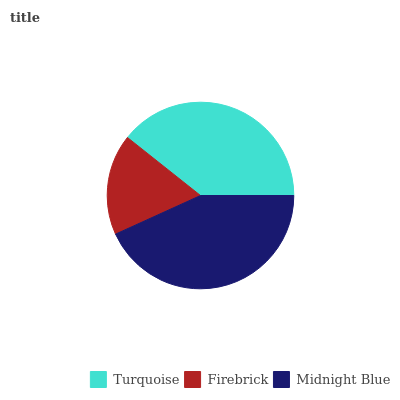Is Firebrick the minimum?
Answer yes or no. Yes. Is Midnight Blue the maximum?
Answer yes or no. Yes. Is Midnight Blue the minimum?
Answer yes or no. No. Is Firebrick the maximum?
Answer yes or no. No. Is Midnight Blue greater than Firebrick?
Answer yes or no. Yes. Is Firebrick less than Midnight Blue?
Answer yes or no. Yes. Is Firebrick greater than Midnight Blue?
Answer yes or no. No. Is Midnight Blue less than Firebrick?
Answer yes or no. No. Is Turquoise the high median?
Answer yes or no. Yes. Is Turquoise the low median?
Answer yes or no. Yes. Is Midnight Blue the high median?
Answer yes or no. No. Is Firebrick the low median?
Answer yes or no. No. 